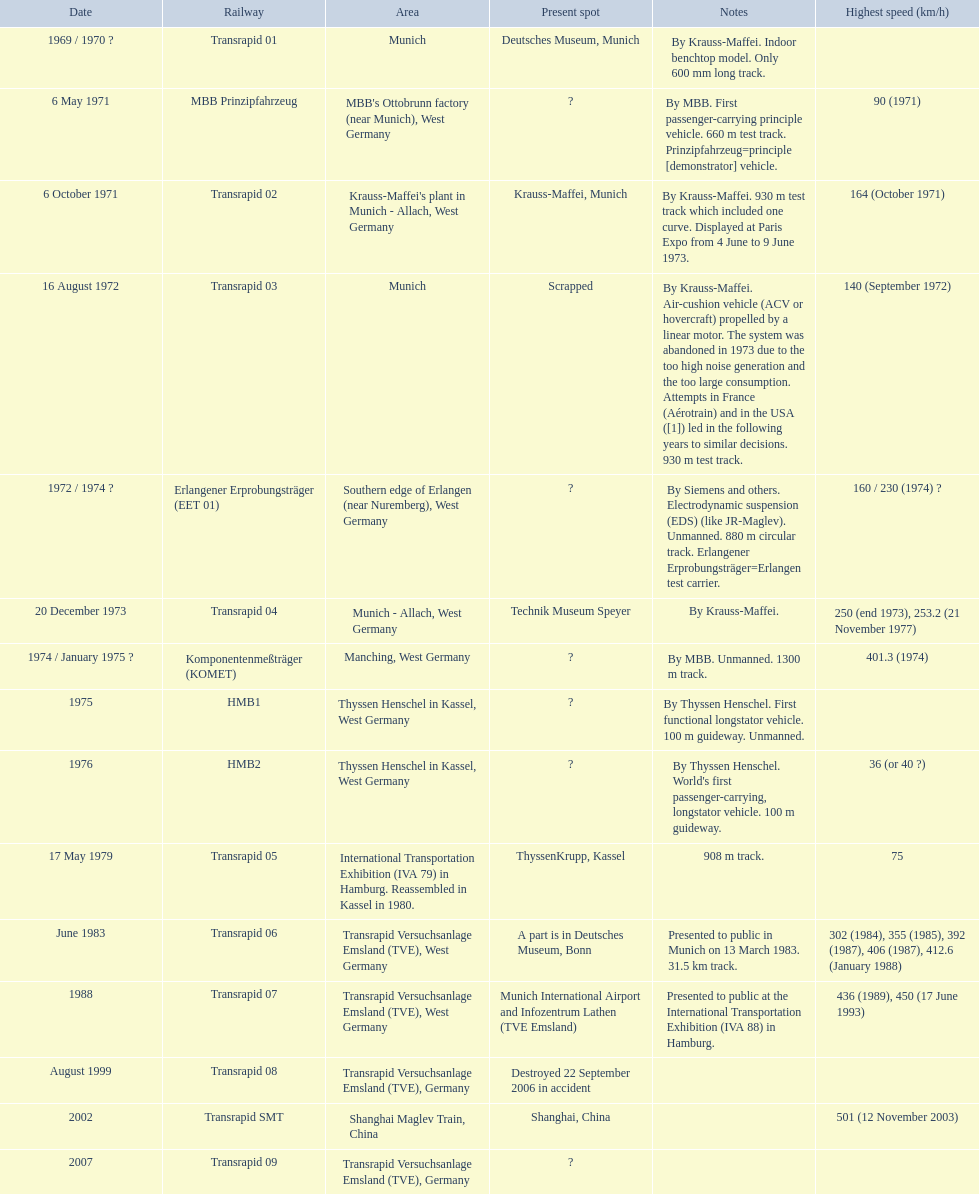Which trains had a top speed listed? MBB Prinzipfahrzeug, Transrapid 02, Transrapid 03, Erlangener Erprobungsträger (EET 01), Transrapid 04, Komponentenmeßträger (KOMET), HMB2, Transrapid 05, Transrapid 06, Transrapid 07, Transrapid SMT. Which ones list munich as a location? MBB Prinzipfahrzeug, Transrapid 02, Transrapid 03. Of these which ones present location is known? Transrapid 02, Transrapid 03. Which of those is no longer in operation? Transrapid 03. 